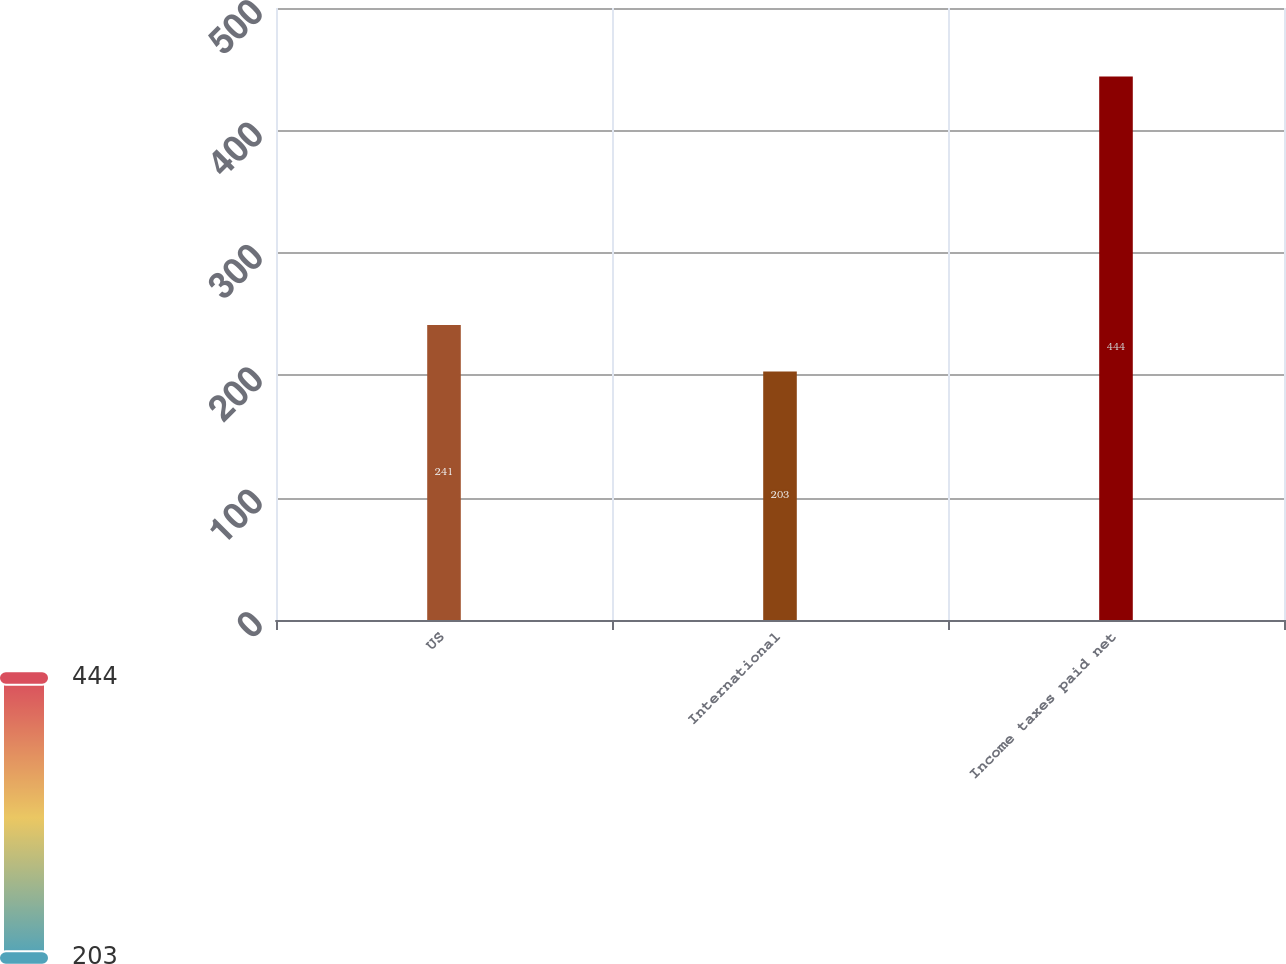Convert chart. <chart><loc_0><loc_0><loc_500><loc_500><bar_chart><fcel>US<fcel>International<fcel>Income taxes paid net<nl><fcel>241<fcel>203<fcel>444<nl></chart> 